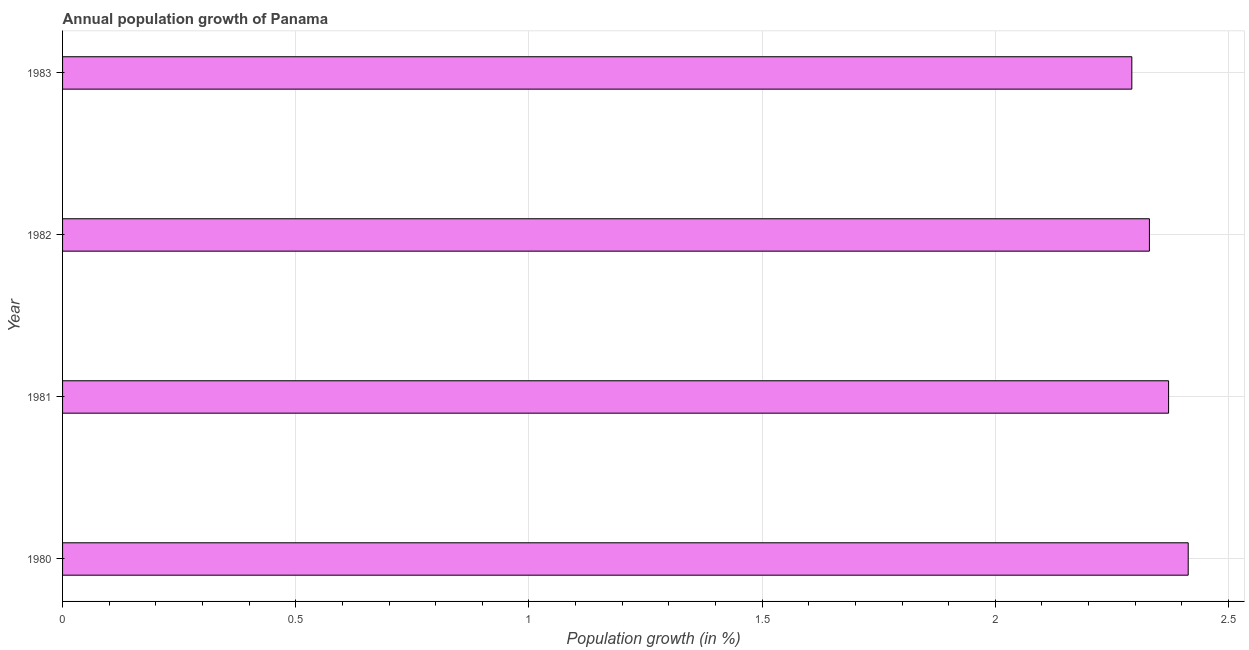Does the graph contain grids?
Make the answer very short. Yes. What is the title of the graph?
Offer a terse response. Annual population growth of Panama. What is the label or title of the X-axis?
Provide a succinct answer. Population growth (in %). What is the label or title of the Y-axis?
Make the answer very short. Year. What is the population growth in 1981?
Make the answer very short. 2.37. Across all years, what is the maximum population growth?
Offer a terse response. 2.41. Across all years, what is the minimum population growth?
Your answer should be compact. 2.29. In which year was the population growth maximum?
Keep it short and to the point. 1980. In which year was the population growth minimum?
Offer a very short reply. 1983. What is the sum of the population growth?
Make the answer very short. 9.41. What is the difference between the population growth in 1980 and 1983?
Ensure brevity in your answer.  0.12. What is the average population growth per year?
Your response must be concise. 2.35. What is the median population growth?
Keep it short and to the point. 2.35. In how many years, is the population growth greater than 1.8 %?
Keep it short and to the point. 4. Is the population growth in 1980 less than that in 1983?
Give a very brief answer. No. What is the difference between the highest and the second highest population growth?
Your response must be concise. 0.04. Is the sum of the population growth in 1980 and 1982 greater than the maximum population growth across all years?
Offer a terse response. Yes. What is the difference between the highest and the lowest population growth?
Provide a succinct answer. 0.12. How many bars are there?
Make the answer very short. 4. Are all the bars in the graph horizontal?
Ensure brevity in your answer.  Yes. Are the values on the major ticks of X-axis written in scientific E-notation?
Ensure brevity in your answer.  No. What is the Population growth (in %) in 1980?
Keep it short and to the point. 2.41. What is the Population growth (in %) of 1981?
Make the answer very short. 2.37. What is the Population growth (in %) in 1982?
Give a very brief answer. 2.33. What is the Population growth (in %) in 1983?
Your response must be concise. 2.29. What is the difference between the Population growth (in %) in 1980 and 1981?
Your answer should be compact. 0.04. What is the difference between the Population growth (in %) in 1980 and 1982?
Your answer should be compact. 0.08. What is the difference between the Population growth (in %) in 1980 and 1983?
Provide a succinct answer. 0.12. What is the difference between the Population growth (in %) in 1981 and 1982?
Provide a succinct answer. 0.04. What is the difference between the Population growth (in %) in 1981 and 1983?
Give a very brief answer. 0.08. What is the difference between the Population growth (in %) in 1982 and 1983?
Your answer should be very brief. 0.04. What is the ratio of the Population growth (in %) in 1980 to that in 1982?
Keep it short and to the point. 1.04. What is the ratio of the Population growth (in %) in 1980 to that in 1983?
Your answer should be very brief. 1.05. What is the ratio of the Population growth (in %) in 1981 to that in 1982?
Provide a short and direct response. 1.02. What is the ratio of the Population growth (in %) in 1981 to that in 1983?
Make the answer very short. 1.03. What is the ratio of the Population growth (in %) in 1982 to that in 1983?
Make the answer very short. 1.02. 